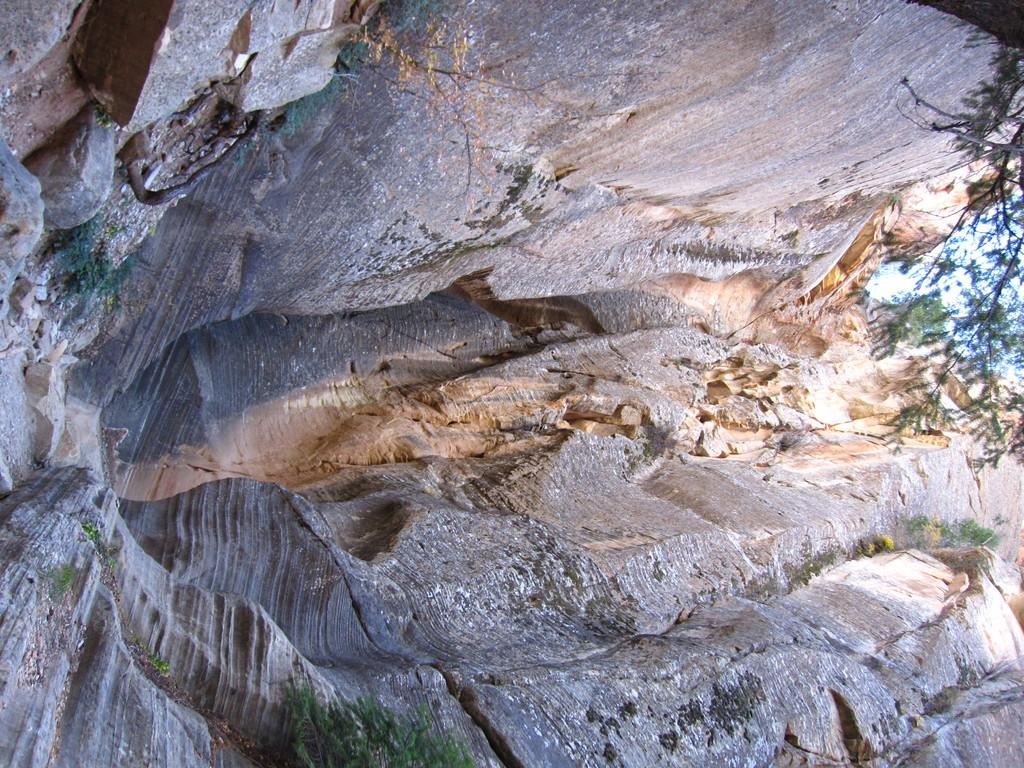What is the largest object in the image? There is a big rock in the image. What type of vegetation can be seen in the image? There are trees in the image. What type of meal is being prepared in the image? There is no meal preparation visible in the image; it only features a big rock and trees. What language is spoken by the man in the image? There is no man present in the image, so it is not possible to determine the language being spoken. 